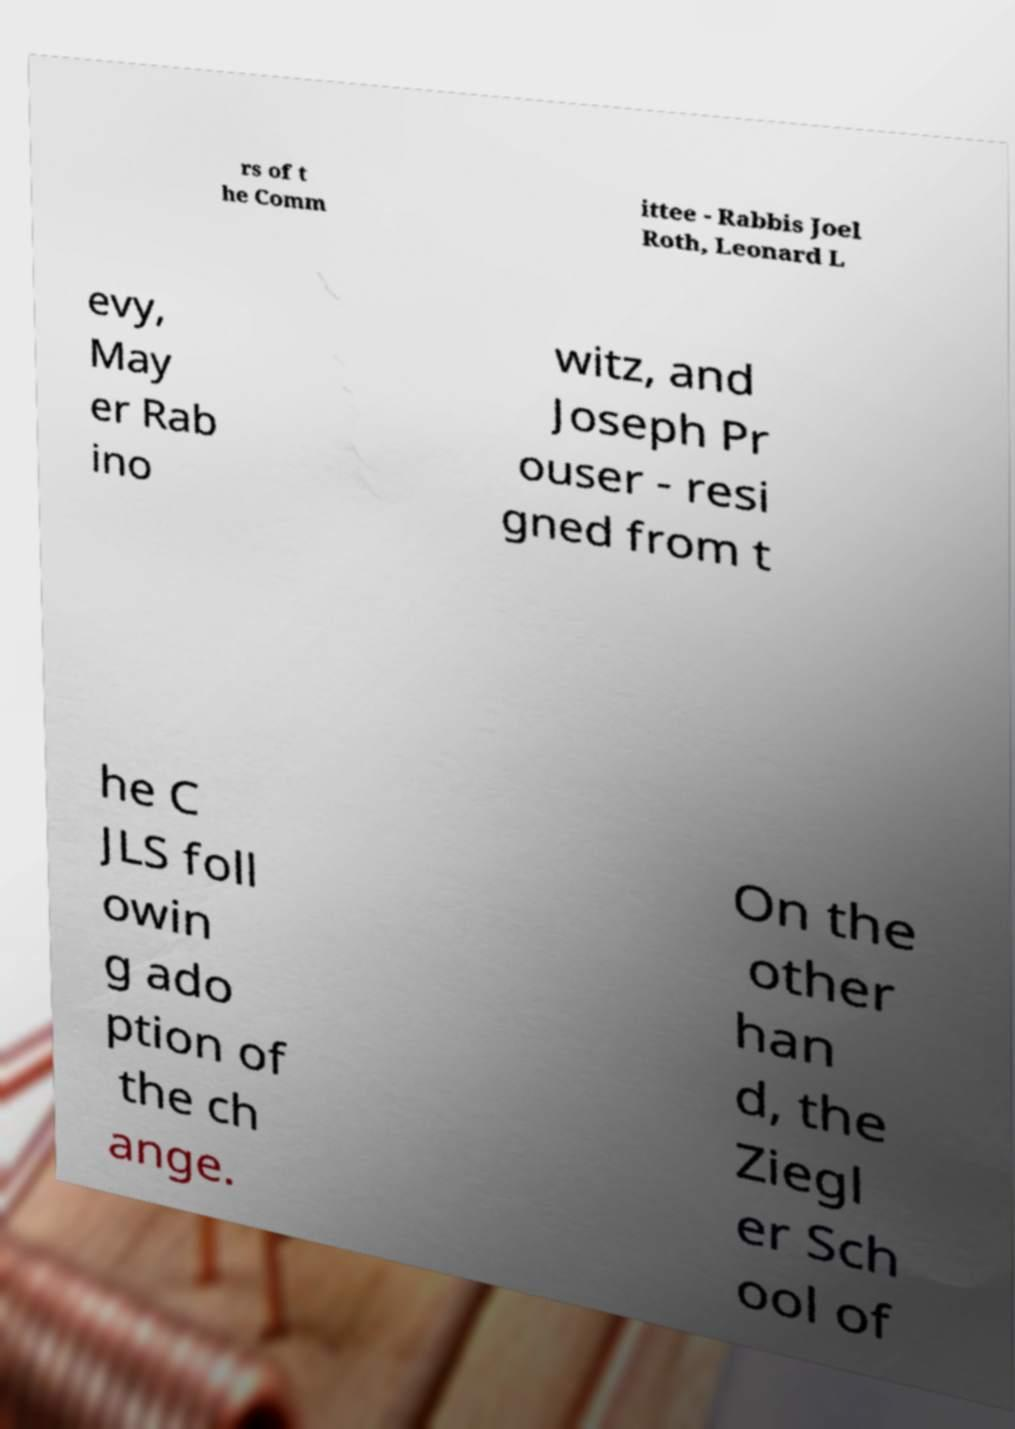What messages or text are displayed in this image? I need them in a readable, typed format. rs of t he Comm ittee - Rabbis Joel Roth, Leonard L evy, May er Rab ino witz, and Joseph Pr ouser - resi gned from t he C JLS foll owin g ado ption of the ch ange. On the other han d, the Ziegl er Sch ool of 